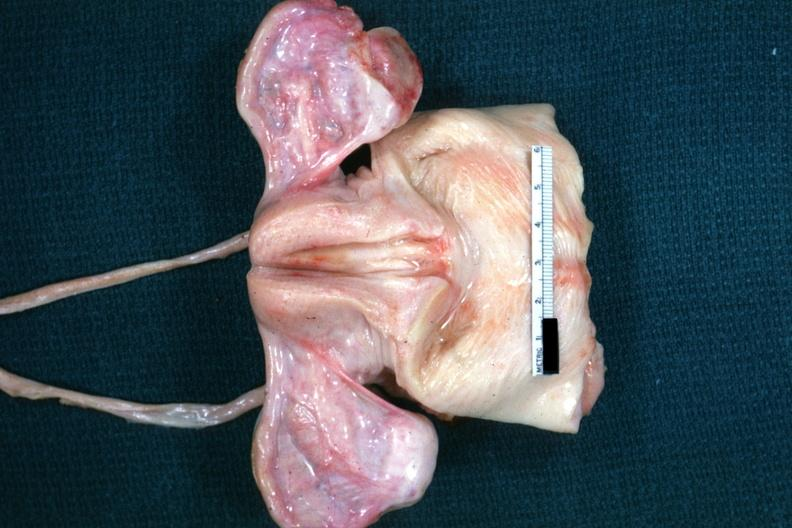what are non functional in this case of vacant sella but externally i can see nothing?
Answer the question using a single word or phrase. Not truly normal ovaries 